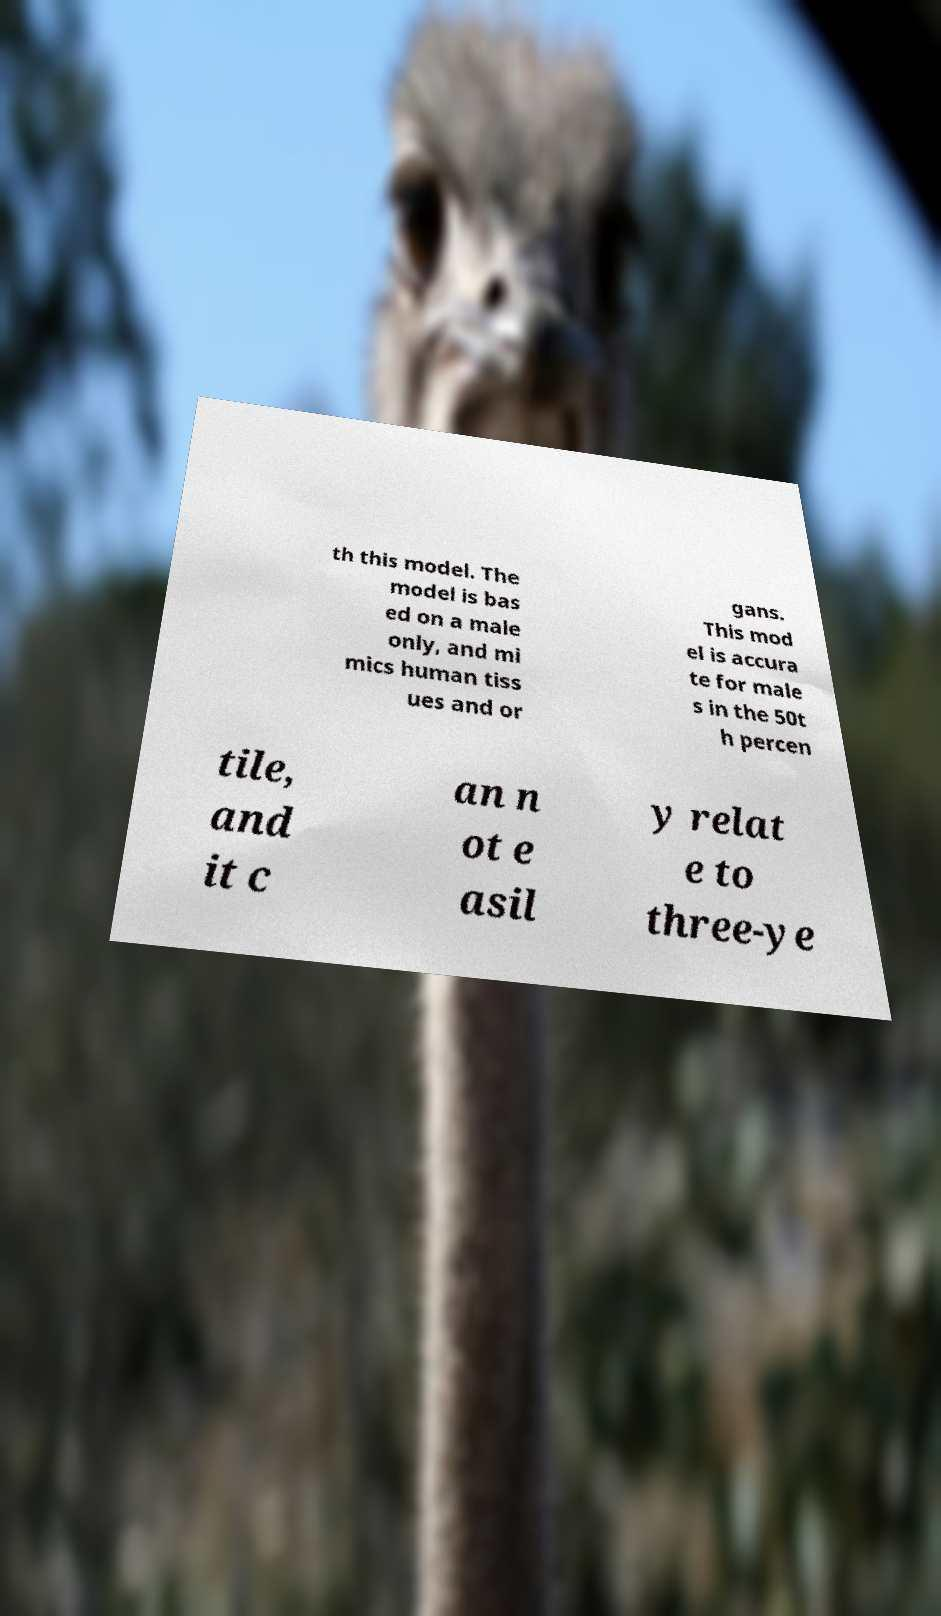For documentation purposes, I need the text within this image transcribed. Could you provide that? th this model. The model is bas ed on a male only, and mi mics human tiss ues and or gans. This mod el is accura te for male s in the 50t h percen tile, and it c an n ot e asil y relat e to three-ye 